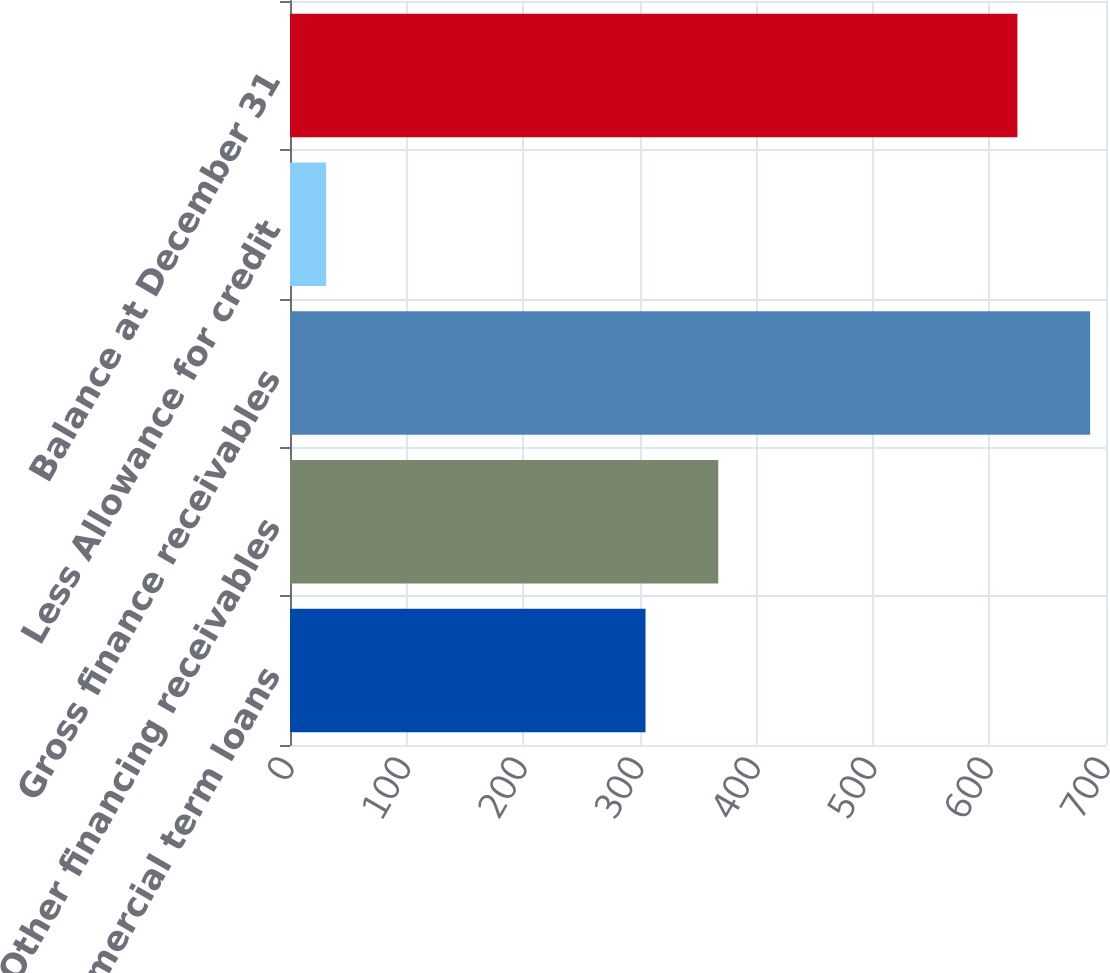Convert chart. <chart><loc_0><loc_0><loc_500><loc_500><bar_chart><fcel>Commercial term loans<fcel>Other financing receivables<fcel>Gross finance receivables<fcel>Less Allowance for credit<fcel>Balance at December 31<nl><fcel>305<fcel>367.4<fcel>686.4<fcel>31<fcel>624<nl></chart> 